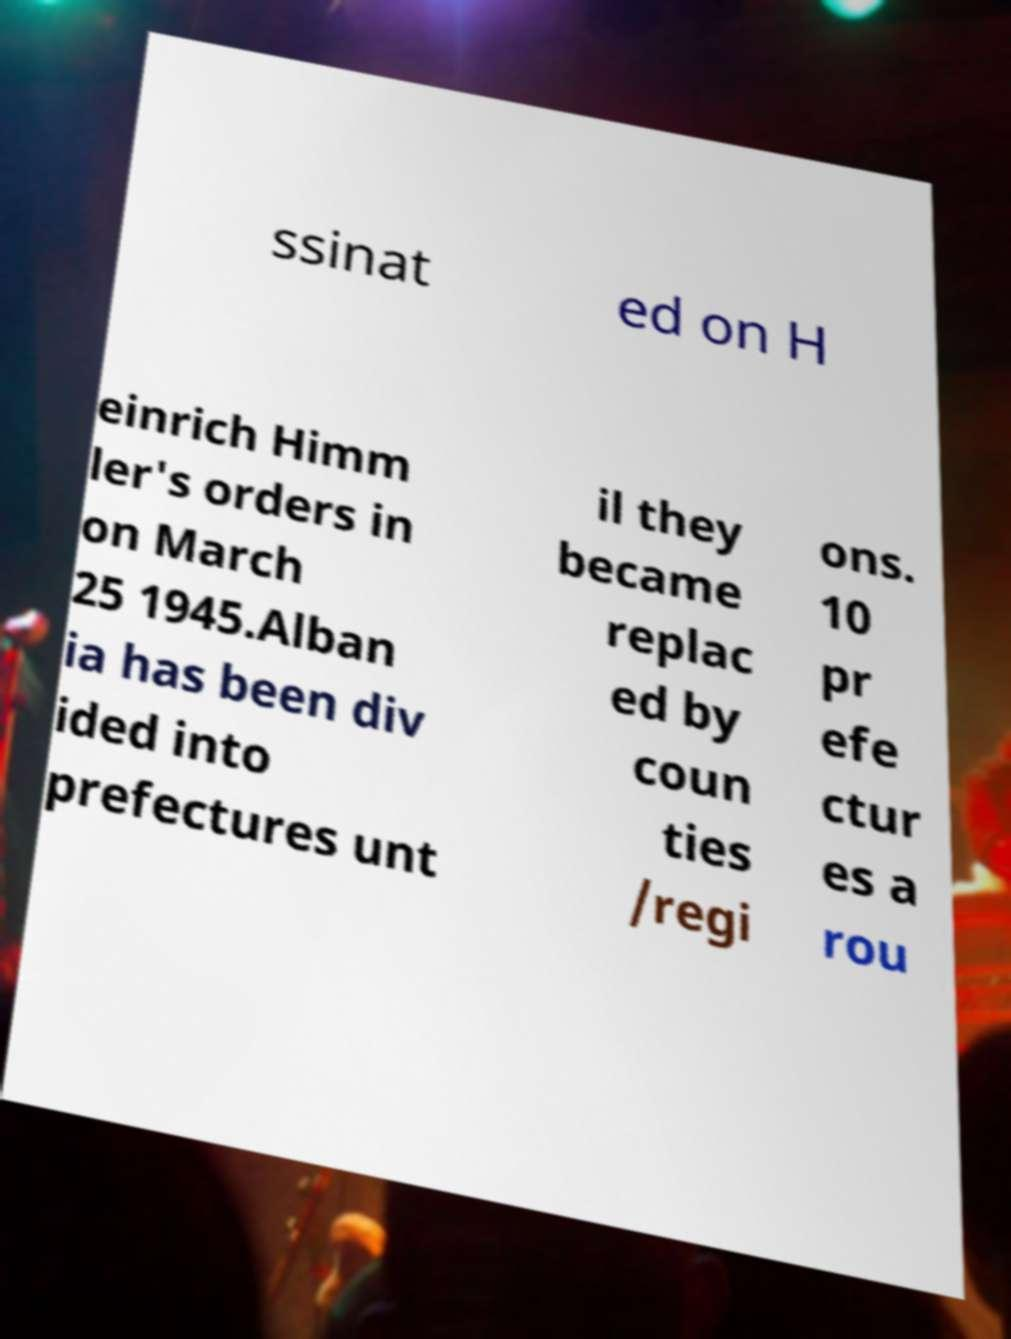Could you assist in decoding the text presented in this image and type it out clearly? ssinat ed on H einrich Himm ler's orders in on March 25 1945.Alban ia has been div ided into prefectures unt il they became replac ed by coun ties /regi ons. 10 pr efe ctur es a rou 